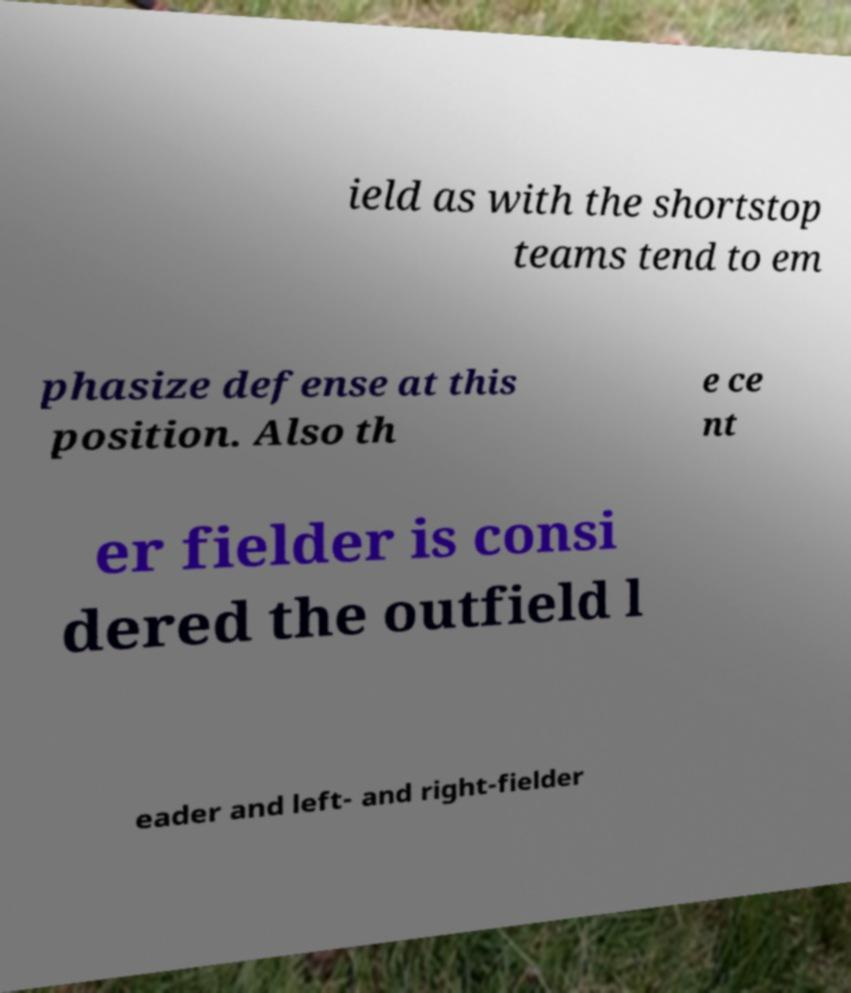Could you assist in decoding the text presented in this image and type it out clearly? ield as with the shortstop teams tend to em phasize defense at this position. Also th e ce nt er fielder is consi dered the outfield l eader and left- and right-fielder 